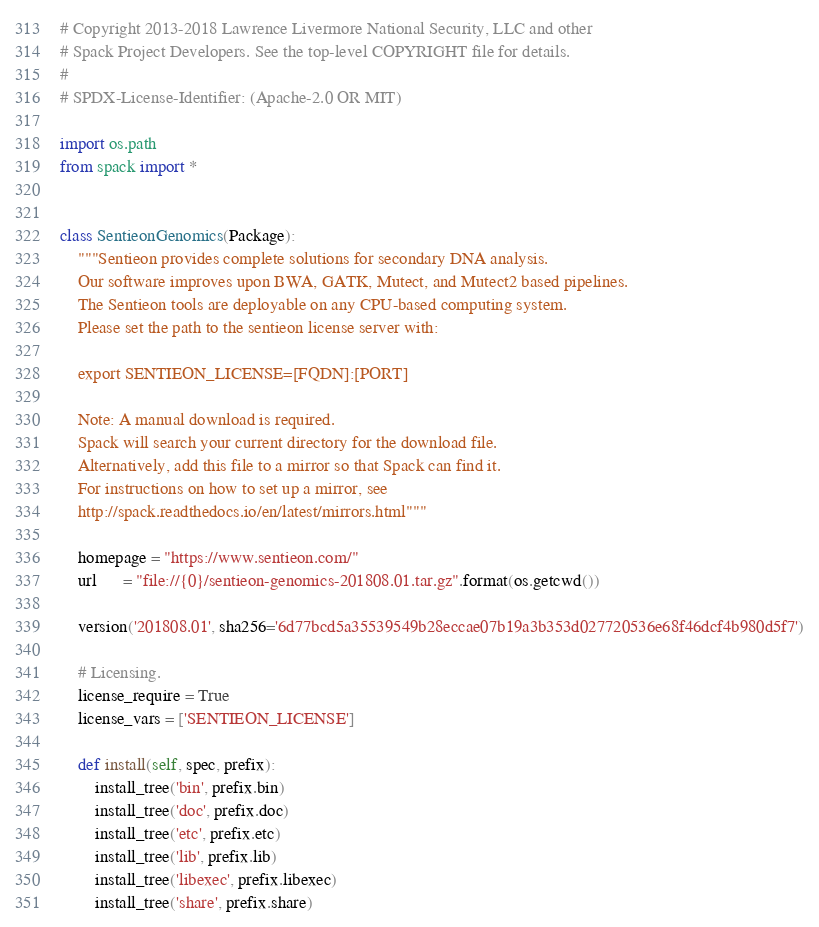<code> <loc_0><loc_0><loc_500><loc_500><_Python_># Copyright 2013-2018 Lawrence Livermore National Security, LLC and other
# Spack Project Developers. See the top-level COPYRIGHT file for details.
#
# SPDX-License-Identifier: (Apache-2.0 OR MIT)

import os.path
from spack import *


class SentieonGenomics(Package):
    """Sentieon provides complete solutions for secondary DNA analysis.
    Our software improves upon BWA, GATK, Mutect, and Mutect2 based pipelines.
    The Sentieon tools are deployable on any CPU-based computing system.
    Please set the path to the sentieon license server with:

    export SENTIEON_LICENSE=[FQDN]:[PORT]

    Note: A manual download is required.
    Spack will search your current directory for the download file.
    Alternatively, add this file to a mirror so that Spack can find it.
    For instructions on how to set up a mirror, see
    http://spack.readthedocs.io/en/latest/mirrors.html"""

    homepage = "https://www.sentieon.com/"
    url      = "file://{0}/sentieon-genomics-201808.01.tar.gz".format(os.getcwd())

    version('201808.01', sha256='6d77bcd5a35539549b28eccae07b19a3b353d027720536e68f46dcf4b980d5f7')

    # Licensing.
    license_require = True
    license_vars = ['SENTIEON_LICENSE']

    def install(self, spec, prefix):
        install_tree('bin', prefix.bin)
        install_tree('doc', prefix.doc)
        install_tree('etc', prefix.etc)
        install_tree('lib', prefix.lib)
        install_tree('libexec', prefix.libexec)
        install_tree('share', prefix.share)
</code> 